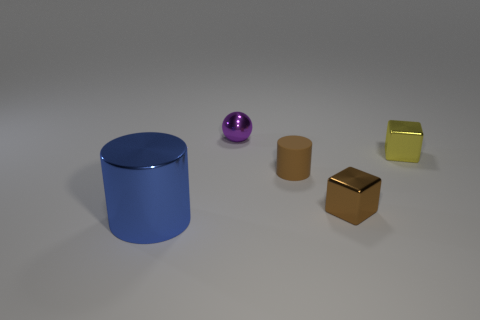Subtract all blue cylinders. How many cylinders are left? 1 Add 4 blue things. How many objects exist? 9 Subtract all cylinders. How many objects are left? 3 Add 1 purple shiny cubes. How many purple shiny cubes exist? 1 Subtract 1 blue cylinders. How many objects are left? 4 Subtract all cyan spheres. Subtract all brown cylinders. How many spheres are left? 1 Subtract all gray blocks. How many blue cylinders are left? 1 Subtract all tiny brown cylinders. Subtract all brown cubes. How many objects are left? 3 Add 3 blocks. How many blocks are left? 5 